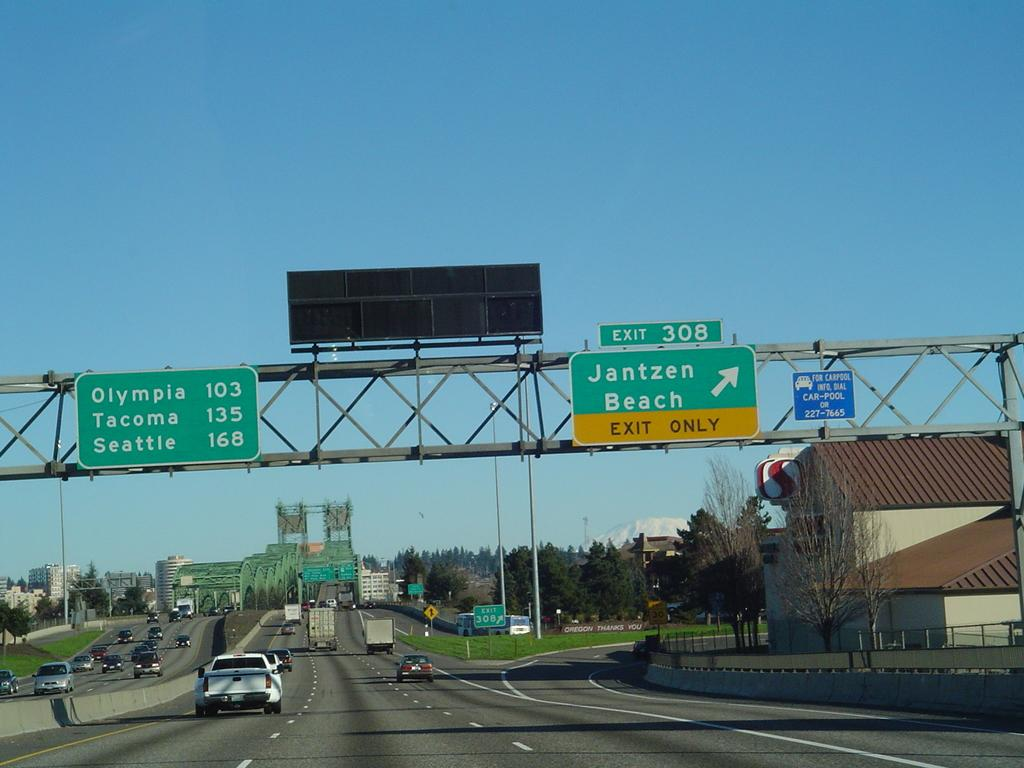<image>
Summarize the visual content of the image. Seattle is on this highway past Olympia and Tacoma. 